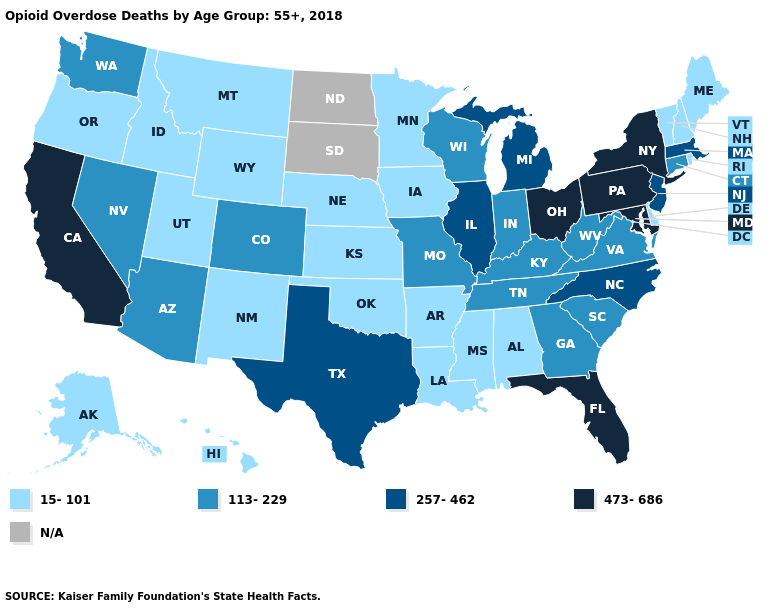Among the states that border Connecticut , does Rhode Island have the lowest value?
Short answer required. Yes. Does California have the highest value in the West?
Short answer required. Yes. Does Ohio have the highest value in the MidWest?
Write a very short answer. Yes. What is the value of Kentucky?
Concise answer only. 113-229. What is the value of New York?
Short answer required. 473-686. Name the states that have a value in the range 15-101?
Be succinct. Alabama, Alaska, Arkansas, Delaware, Hawaii, Idaho, Iowa, Kansas, Louisiana, Maine, Minnesota, Mississippi, Montana, Nebraska, New Hampshire, New Mexico, Oklahoma, Oregon, Rhode Island, Utah, Vermont, Wyoming. Which states have the highest value in the USA?
Answer briefly. California, Florida, Maryland, New York, Ohio, Pennsylvania. What is the value of Oregon?
Be succinct. 15-101. What is the value of Tennessee?
Give a very brief answer. 113-229. What is the value of Michigan?
Quick response, please. 257-462. Does Rhode Island have the lowest value in the Northeast?
Write a very short answer. Yes. Name the states that have a value in the range 473-686?
Concise answer only. California, Florida, Maryland, New York, Ohio, Pennsylvania. Does Minnesota have the highest value in the MidWest?
Short answer required. No. 